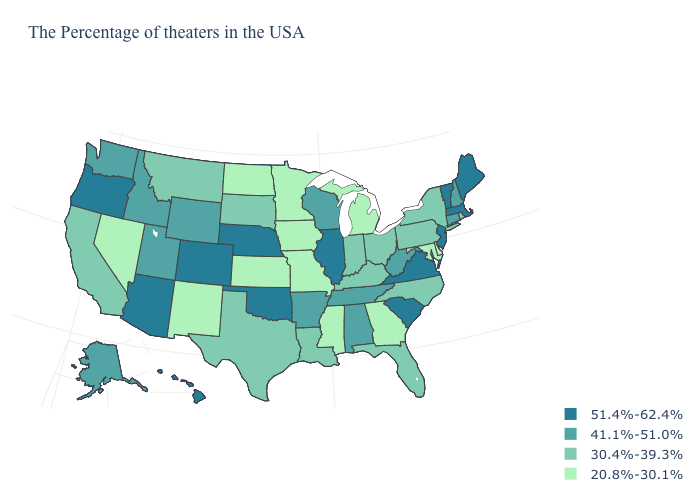Which states have the highest value in the USA?
Answer briefly. Maine, Massachusetts, Vermont, New Jersey, Virginia, South Carolina, Illinois, Nebraska, Oklahoma, Colorado, Arizona, Oregon, Hawaii. Does Massachusetts have the highest value in the USA?
Write a very short answer. Yes. Does Vermont have a higher value than Louisiana?
Concise answer only. Yes. Does Mississippi have the lowest value in the South?
Be succinct. Yes. Does Pennsylvania have the highest value in the Northeast?
Give a very brief answer. No. Does North Carolina have the same value as New York?
Concise answer only. Yes. Does Minnesota have the lowest value in the USA?
Concise answer only. Yes. Name the states that have a value in the range 20.8%-30.1%?
Answer briefly. Delaware, Maryland, Georgia, Michigan, Mississippi, Missouri, Minnesota, Iowa, Kansas, North Dakota, New Mexico, Nevada. Which states have the lowest value in the MidWest?
Give a very brief answer. Michigan, Missouri, Minnesota, Iowa, Kansas, North Dakota. What is the value of Louisiana?
Short answer required. 30.4%-39.3%. What is the highest value in states that border Idaho?
Concise answer only. 51.4%-62.4%. What is the highest value in states that border Pennsylvania?
Write a very short answer. 51.4%-62.4%. Name the states that have a value in the range 30.4%-39.3%?
Concise answer only. Rhode Island, New York, Pennsylvania, North Carolina, Ohio, Florida, Kentucky, Indiana, Louisiana, Texas, South Dakota, Montana, California. Name the states that have a value in the range 51.4%-62.4%?
Short answer required. Maine, Massachusetts, Vermont, New Jersey, Virginia, South Carolina, Illinois, Nebraska, Oklahoma, Colorado, Arizona, Oregon, Hawaii. Which states have the highest value in the USA?
Give a very brief answer. Maine, Massachusetts, Vermont, New Jersey, Virginia, South Carolina, Illinois, Nebraska, Oklahoma, Colorado, Arizona, Oregon, Hawaii. 